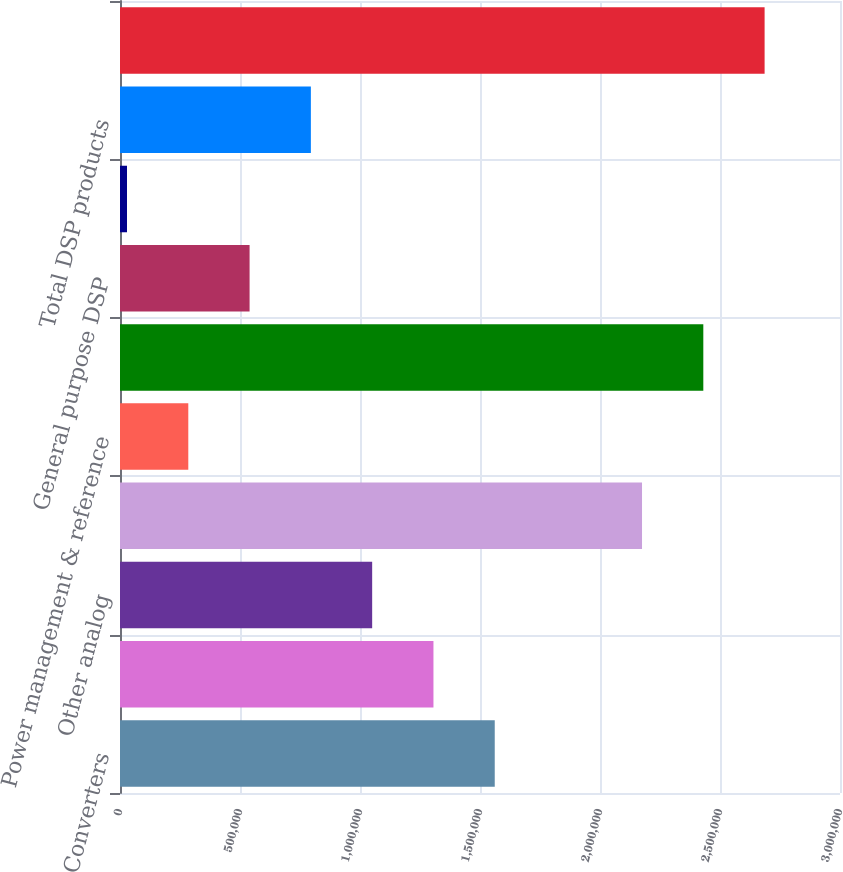<chart> <loc_0><loc_0><loc_500><loc_500><bar_chart><fcel>Converters<fcel>Amplifiers<fcel>Other analog<fcel>Subtotal analog signal<fcel>Power management & reference<fcel>Total analog products<fcel>General purpose DSP<fcel>Other DSP<fcel>Total DSP products<fcel>Total Product Revenue<nl><fcel>1.56143e+06<fcel>1.30606e+06<fcel>1.05069e+06<fcel>2.1751e+06<fcel>284562<fcel>2.43047e+06<fcel>539937<fcel>29188<fcel>795311<fcel>2.68585e+06<nl></chart> 